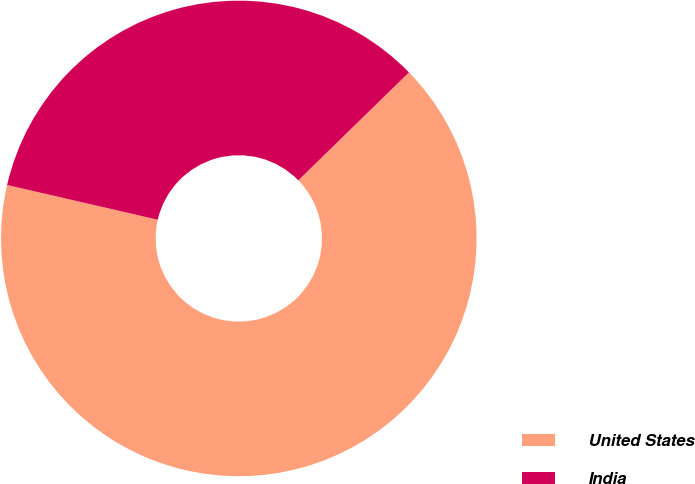<chart> <loc_0><loc_0><loc_500><loc_500><pie_chart><fcel>United States<fcel>India<nl><fcel>65.91%<fcel>34.09%<nl></chart> 